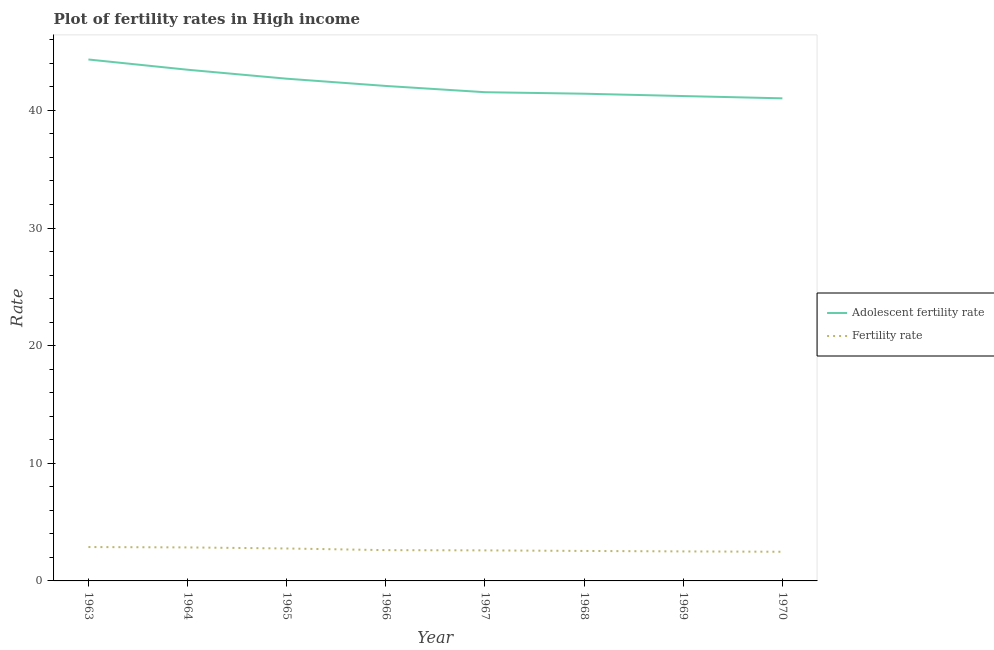How many different coloured lines are there?
Make the answer very short. 2. Is the number of lines equal to the number of legend labels?
Offer a terse response. Yes. What is the adolescent fertility rate in 1969?
Ensure brevity in your answer.  41.22. Across all years, what is the maximum adolescent fertility rate?
Your response must be concise. 44.33. Across all years, what is the minimum adolescent fertility rate?
Provide a short and direct response. 41.03. What is the total adolescent fertility rate in the graph?
Provide a short and direct response. 337.78. What is the difference between the adolescent fertility rate in 1965 and that in 1969?
Offer a terse response. 1.48. What is the difference between the fertility rate in 1964 and the adolescent fertility rate in 1970?
Your answer should be very brief. -38.18. What is the average adolescent fertility rate per year?
Your response must be concise. 42.22. In the year 1970, what is the difference between the adolescent fertility rate and fertility rate?
Give a very brief answer. 38.55. What is the ratio of the fertility rate in 1968 to that in 1970?
Provide a short and direct response. 1.03. What is the difference between the highest and the second highest adolescent fertility rate?
Your response must be concise. 0.87. What is the difference between the highest and the lowest adolescent fertility rate?
Ensure brevity in your answer.  3.3. In how many years, is the adolescent fertility rate greater than the average adolescent fertility rate taken over all years?
Your answer should be very brief. 3. Is the fertility rate strictly less than the adolescent fertility rate over the years?
Make the answer very short. Yes. How many lines are there?
Keep it short and to the point. 2. How many years are there in the graph?
Keep it short and to the point. 8. Does the graph contain any zero values?
Offer a very short reply. No. Does the graph contain grids?
Provide a short and direct response. No. Where does the legend appear in the graph?
Give a very brief answer. Center right. What is the title of the graph?
Give a very brief answer. Plot of fertility rates in High income. What is the label or title of the X-axis?
Your response must be concise. Year. What is the label or title of the Y-axis?
Give a very brief answer. Rate. What is the Rate in Adolescent fertility rate in 1963?
Offer a terse response. 44.33. What is the Rate of Fertility rate in 1963?
Provide a short and direct response. 2.88. What is the Rate in Adolescent fertility rate in 1964?
Ensure brevity in your answer.  43.46. What is the Rate of Fertility rate in 1964?
Your answer should be very brief. 2.85. What is the Rate in Adolescent fertility rate in 1965?
Your answer should be very brief. 42.7. What is the Rate in Fertility rate in 1965?
Give a very brief answer. 2.76. What is the Rate in Adolescent fertility rate in 1966?
Provide a short and direct response. 42.08. What is the Rate of Fertility rate in 1966?
Your response must be concise. 2.62. What is the Rate in Adolescent fertility rate in 1967?
Your answer should be compact. 41.55. What is the Rate of Fertility rate in 1967?
Ensure brevity in your answer.  2.6. What is the Rate of Adolescent fertility rate in 1968?
Provide a succinct answer. 41.42. What is the Rate of Fertility rate in 1968?
Your answer should be compact. 2.55. What is the Rate in Adolescent fertility rate in 1969?
Provide a succinct answer. 41.22. What is the Rate of Fertility rate in 1969?
Ensure brevity in your answer.  2.51. What is the Rate in Adolescent fertility rate in 1970?
Your answer should be compact. 41.03. What is the Rate of Fertility rate in 1970?
Make the answer very short. 2.48. Across all years, what is the maximum Rate in Adolescent fertility rate?
Your answer should be very brief. 44.33. Across all years, what is the maximum Rate of Fertility rate?
Offer a very short reply. 2.88. Across all years, what is the minimum Rate in Adolescent fertility rate?
Your response must be concise. 41.03. Across all years, what is the minimum Rate of Fertility rate?
Give a very brief answer. 2.48. What is the total Rate in Adolescent fertility rate in the graph?
Offer a terse response. 337.78. What is the total Rate in Fertility rate in the graph?
Make the answer very short. 21.24. What is the difference between the Rate of Adolescent fertility rate in 1963 and that in 1964?
Ensure brevity in your answer.  0.87. What is the difference between the Rate of Fertility rate in 1963 and that in 1964?
Give a very brief answer. 0.03. What is the difference between the Rate in Adolescent fertility rate in 1963 and that in 1965?
Provide a short and direct response. 1.63. What is the difference between the Rate in Fertility rate in 1963 and that in 1965?
Offer a very short reply. 0.12. What is the difference between the Rate of Adolescent fertility rate in 1963 and that in 1966?
Provide a short and direct response. 2.25. What is the difference between the Rate in Fertility rate in 1963 and that in 1966?
Give a very brief answer. 0.26. What is the difference between the Rate of Adolescent fertility rate in 1963 and that in 1967?
Your answer should be compact. 2.78. What is the difference between the Rate of Fertility rate in 1963 and that in 1967?
Your answer should be very brief. 0.28. What is the difference between the Rate in Adolescent fertility rate in 1963 and that in 1968?
Keep it short and to the point. 2.91. What is the difference between the Rate of Fertility rate in 1963 and that in 1968?
Your response must be concise. 0.33. What is the difference between the Rate in Adolescent fertility rate in 1963 and that in 1969?
Provide a short and direct response. 3.11. What is the difference between the Rate in Fertility rate in 1963 and that in 1969?
Your answer should be compact. 0.37. What is the difference between the Rate in Adolescent fertility rate in 1963 and that in 1970?
Your answer should be compact. 3.3. What is the difference between the Rate in Fertility rate in 1963 and that in 1970?
Offer a terse response. 0.4. What is the difference between the Rate of Adolescent fertility rate in 1964 and that in 1965?
Give a very brief answer. 0.76. What is the difference between the Rate in Fertility rate in 1964 and that in 1965?
Offer a very short reply. 0.09. What is the difference between the Rate of Adolescent fertility rate in 1964 and that in 1966?
Provide a short and direct response. 1.38. What is the difference between the Rate in Fertility rate in 1964 and that in 1966?
Your response must be concise. 0.23. What is the difference between the Rate in Adolescent fertility rate in 1964 and that in 1967?
Provide a short and direct response. 1.91. What is the difference between the Rate of Fertility rate in 1964 and that in 1967?
Offer a terse response. 0.25. What is the difference between the Rate of Adolescent fertility rate in 1964 and that in 1968?
Your answer should be very brief. 2.04. What is the difference between the Rate of Fertility rate in 1964 and that in 1968?
Offer a terse response. 0.3. What is the difference between the Rate of Adolescent fertility rate in 1964 and that in 1969?
Your answer should be compact. 2.24. What is the difference between the Rate of Fertility rate in 1964 and that in 1969?
Provide a short and direct response. 0.34. What is the difference between the Rate in Adolescent fertility rate in 1964 and that in 1970?
Provide a short and direct response. 2.43. What is the difference between the Rate in Fertility rate in 1964 and that in 1970?
Your answer should be compact. 0.37. What is the difference between the Rate in Adolescent fertility rate in 1965 and that in 1966?
Keep it short and to the point. 0.62. What is the difference between the Rate in Fertility rate in 1965 and that in 1966?
Your response must be concise. 0.14. What is the difference between the Rate in Adolescent fertility rate in 1965 and that in 1967?
Your answer should be compact. 1.15. What is the difference between the Rate in Fertility rate in 1965 and that in 1967?
Your response must be concise. 0.16. What is the difference between the Rate in Adolescent fertility rate in 1965 and that in 1968?
Ensure brevity in your answer.  1.28. What is the difference between the Rate in Fertility rate in 1965 and that in 1968?
Provide a succinct answer. 0.21. What is the difference between the Rate in Adolescent fertility rate in 1965 and that in 1969?
Your answer should be very brief. 1.48. What is the difference between the Rate in Fertility rate in 1965 and that in 1969?
Your answer should be compact. 0.25. What is the difference between the Rate of Adolescent fertility rate in 1965 and that in 1970?
Offer a terse response. 1.67. What is the difference between the Rate of Fertility rate in 1965 and that in 1970?
Offer a terse response. 0.28. What is the difference between the Rate of Adolescent fertility rate in 1966 and that in 1967?
Offer a terse response. 0.53. What is the difference between the Rate in Fertility rate in 1966 and that in 1967?
Provide a succinct answer. 0.02. What is the difference between the Rate of Adolescent fertility rate in 1966 and that in 1968?
Make the answer very short. 0.66. What is the difference between the Rate of Fertility rate in 1966 and that in 1968?
Your answer should be very brief. 0.07. What is the difference between the Rate of Adolescent fertility rate in 1966 and that in 1969?
Provide a succinct answer. 0.86. What is the difference between the Rate in Fertility rate in 1966 and that in 1969?
Give a very brief answer. 0.11. What is the difference between the Rate of Adolescent fertility rate in 1966 and that in 1970?
Ensure brevity in your answer.  1.05. What is the difference between the Rate in Fertility rate in 1966 and that in 1970?
Give a very brief answer. 0.14. What is the difference between the Rate in Adolescent fertility rate in 1967 and that in 1968?
Your answer should be compact. 0.13. What is the difference between the Rate in Fertility rate in 1967 and that in 1968?
Offer a terse response. 0.05. What is the difference between the Rate in Adolescent fertility rate in 1967 and that in 1969?
Your answer should be compact. 0.33. What is the difference between the Rate of Fertility rate in 1967 and that in 1969?
Provide a short and direct response. 0.09. What is the difference between the Rate of Adolescent fertility rate in 1967 and that in 1970?
Your answer should be very brief. 0.52. What is the difference between the Rate of Fertility rate in 1967 and that in 1970?
Your response must be concise. 0.12. What is the difference between the Rate in Adolescent fertility rate in 1968 and that in 1969?
Offer a very short reply. 0.2. What is the difference between the Rate of Fertility rate in 1968 and that in 1969?
Ensure brevity in your answer.  0.04. What is the difference between the Rate in Adolescent fertility rate in 1968 and that in 1970?
Your answer should be very brief. 0.39. What is the difference between the Rate of Fertility rate in 1968 and that in 1970?
Keep it short and to the point. 0.07. What is the difference between the Rate in Adolescent fertility rate in 1969 and that in 1970?
Provide a succinct answer. 0.19. What is the difference between the Rate in Fertility rate in 1969 and that in 1970?
Your answer should be very brief. 0.03. What is the difference between the Rate of Adolescent fertility rate in 1963 and the Rate of Fertility rate in 1964?
Provide a succinct answer. 41.48. What is the difference between the Rate in Adolescent fertility rate in 1963 and the Rate in Fertility rate in 1965?
Make the answer very short. 41.57. What is the difference between the Rate of Adolescent fertility rate in 1963 and the Rate of Fertility rate in 1966?
Your answer should be compact. 41.71. What is the difference between the Rate in Adolescent fertility rate in 1963 and the Rate in Fertility rate in 1967?
Provide a succinct answer. 41.73. What is the difference between the Rate of Adolescent fertility rate in 1963 and the Rate of Fertility rate in 1968?
Keep it short and to the point. 41.78. What is the difference between the Rate in Adolescent fertility rate in 1963 and the Rate in Fertility rate in 1969?
Your answer should be compact. 41.82. What is the difference between the Rate of Adolescent fertility rate in 1963 and the Rate of Fertility rate in 1970?
Ensure brevity in your answer.  41.85. What is the difference between the Rate of Adolescent fertility rate in 1964 and the Rate of Fertility rate in 1965?
Offer a very short reply. 40.7. What is the difference between the Rate of Adolescent fertility rate in 1964 and the Rate of Fertility rate in 1966?
Ensure brevity in your answer.  40.84. What is the difference between the Rate of Adolescent fertility rate in 1964 and the Rate of Fertility rate in 1967?
Make the answer very short. 40.86. What is the difference between the Rate in Adolescent fertility rate in 1964 and the Rate in Fertility rate in 1968?
Make the answer very short. 40.91. What is the difference between the Rate in Adolescent fertility rate in 1964 and the Rate in Fertility rate in 1969?
Offer a very short reply. 40.95. What is the difference between the Rate in Adolescent fertility rate in 1964 and the Rate in Fertility rate in 1970?
Keep it short and to the point. 40.98. What is the difference between the Rate in Adolescent fertility rate in 1965 and the Rate in Fertility rate in 1966?
Ensure brevity in your answer.  40.08. What is the difference between the Rate in Adolescent fertility rate in 1965 and the Rate in Fertility rate in 1967?
Offer a very short reply. 40.1. What is the difference between the Rate of Adolescent fertility rate in 1965 and the Rate of Fertility rate in 1968?
Give a very brief answer. 40.15. What is the difference between the Rate in Adolescent fertility rate in 1965 and the Rate in Fertility rate in 1969?
Make the answer very short. 40.19. What is the difference between the Rate in Adolescent fertility rate in 1965 and the Rate in Fertility rate in 1970?
Your answer should be compact. 40.22. What is the difference between the Rate in Adolescent fertility rate in 1966 and the Rate in Fertility rate in 1967?
Offer a terse response. 39.48. What is the difference between the Rate in Adolescent fertility rate in 1966 and the Rate in Fertility rate in 1968?
Provide a succinct answer. 39.53. What is the difference between the Rate of Adolescent fertility rate in 1966 and the Rate of Fertility rate in 1969?
Provide a succinct answer. 39.57. What is the difference between the Rate in Adolescent fertility rate in 1966 and the Rate in Fertility rate in 1970?
Keep it short and to the point. 39.6. What is the difference between the Rate of Adolescent fertility rate in 1967 and the Rate of Fertility rate in 1968?
Your answer should be very brief. 39. What is the difference between the Rate in Adolescent fertility rate in 1967 and the Rate in Fertility rate in 1969?
Make the answer very short. 39.04. What is the difference between the Rate in Adolescent fertility rate in 1967 and the Rate in Fertility rate in 1970?
Make the answer very short. 39.07. What is the difference between the Rate of Adolescent fertility rate in 1968 and the Rate of Fertility rate in 1969?
Keep it short and to the point. 38.91. What is the difference between the Rate in Adolescent fertility rate in 1968 and the Rate in Fertility rate in 1970?
Provide a succinct answer. 38.94. What is the difference between the Rate in Adolescent fertility rate in 1969 and the Rate in Fertility rate in 1970?
Your response must be concise. 38.74. What is the average Rate of Adolescent fertility rate per year?
Your answer should be very brief. 42.22. What is the average Rate of Fertility rate per year?
Keep it short and to the point. 2.65. In the year 1963, what is the difference between the Rate of Adolescent fertility rate and Rate of Fertility rate?
Keep it short and to the point. 41.45. In the year 1964, what is the difference between the Rate in Adolescent fertility rate and Rate in Fertility rate?
Your answer should be very brief. 40.61. In the year 1965, what is the difference between the Rate of Adolescent fertility rate and Rate of Fertility rate?
Ensure brevity in your answer.  39.94. In the year 1966, what is the difference between the Rate of Adolescent fertility rate and Rate of Fertility rate?
Give a very brief answer. 39.46. In the year 1967, what is the difference between the Rate of Adolescent fertility rate and Rate of Fertility rate?
Your answer should be compact. 38.95. In the year 1968, what is the difference between the Rate of Adolescent fertility rate and Rate of Fertility rate?
Your answer should be compact. 38.87. In the year 1969, what is the difference between the Rate of Adolescent fertility rate and Rate of Fertility rate?
Your response must be concise. 38.71. In the year 1970, what is the difference between the Rate in Adolescent fertility rate and Rate in Fertility rate?
Give a very brief answer. 38.55. What is the ratio of the Rate in Adolescent fertility rate in 1963 to that in 1964?
Give a very brief answer. 1.02. What is the ratio of the Rate in Fertility rate in 1963 to that in 1964?
Ensure brevity in your answer.  1.01. What is the ratio of the Rate of Adolescent fertility rate in 1963 to that in 1965?
Offer a terse response. 1.04. What is the ratio of the Rate of Fertility rate in 1963 to that in 1965?
Provide a short and direct response. 1.04. What is the ratio of the Rate of Adolescent fertility rate in 1963 to that in 1966?
Make the answer very short. 1.05. What is the ratio of the Rate in Fertility rate in 1963 to that in 1966?
Your answer should be very brief. 1.1. What is the ratio of the Rate in Adolescent fertility rate in 1963 to that in 1967?
Provide a succinct answer. 1.07. What is the ratio of the Rate of Fertility rate in 1963 to that in 1967?
Provide a succinct answer. 1.11. What is the ratio of the Rate of Adolescent fertility rate in 1963 to that in 1968?
Provide a succinct answer. 1.07. What is the ratio of the Rate in Fertility rate in 1963 to that in 1968?
Ensure brevity in your answer.  1.13. What is the ratio of the Rate in Adolescent fertility rate in 1963 to that in 1969?
Offer a terse response. 1.08. What is the ratio of the Rate in Fertility rate in 1963 to that in 1969?
Make the answer very short. 1.15. What is the ratio of the Rate in Adolescent fertility rate in 1963 to that in 1970?
Offer a terse response. 1.08. What is the ratio of the Rate of Fertility rate in 1963 to that in 1970?
Your answer should be very brief. 1.16. What is the ratio of the Rate of Adolescent fertility rate in 1964 to that in 1965?
Give a very brief answer. 1.02. What is the ratio of the Rate in Fertility rate in 1964 to that in 1965?
Provide a short and direct response. 1.03. What is the ratio of the Rate of Adolescent fertility rate in 1964 to that in 1966?
Provide a succinct answer. 1.03. What is the ratio of the Rate in Fertility rate in 1964 to that in 1966?
Your response must be concise. 1.09. What is the ratio of the Rate of Adolescent fertility rate in 1964 to that in 1967?
Your answer should be very brief. 1.05. What is the ratio of the Rate in Fertility rate in 1964 to that in 1967?
Your response must be concise. 1.1. What is the ratio of the Rate in Adolescent fertility rate in 1964 to that in 1968?
Provide a short and direct response. 1.05. What is the ratio of the Rate in Fertility rate in 1964 to that in 1968?
Your answer should be very brief. 1.12. What is the ratio of the Rate of Adolescent fertility rate in 1964 to that in 1969?
Make the answer very short. 1.05. What is the ratio of the Rate of Fertility rate in 1964 to that in 1969?
Provide a short and direct response. 1.14. What is the ratio of the Rate in Adolescent fertility rate in 1964 to that in 1970?
Offer a terse response. 1.06. What is the ratio of the Rate in Fertility rate in 1964 to that in 1970?
Ensure brevity in your answer.  1.15. What is the ratio of the Rate in Adolescent fertility rate in 1965 to that in 1966?
Offer a terse response. 1.01. What is the ratio of the Rate of Fertility rate in 1965 to that in 1966?
Offer a terse response. 1.05. What is the ratio of the Rate of Adolescent fertility rate in 1965 to that in 1967?
Provide a succinct answer. 1.03. What is the ratio of the Rate in Fertility rate in 1965 to that in 1967?
Ensure brevity in your answer.  1.06. What is the ratio of the Rate in Adolescent fertility rate in 1965 to that in 1968?
Your answer should be very brief. 1.03. What is the ratio of the Rate in Fertility rate in 1965 to that in 1968?
Your answer should be very brief. 1.08. What is the ratio of the Rate in Adolescent fertility rate in 1965 to that in 1969?
Your answer should be very brief. 1.04. What is the ratio of the Rate in Fertility rate in 1965 to that in 1969?
Offer a very short reply. 1.1. What is the ratio of the Rate of Adolescent fertility rate in 1965 to that in 1970?
Provide a succinct answer. 1.04. What is the ratio of the Rate of Fertility rate in 1965 to that in 1970?
Give a very brief answer. 1.11. What is the ratio of the Rate in Adolescent fertility rate in 1966 to that in 1967?
Your answer should be compact. 1.01. What is the ratio of the Rate of Fertility rate in 1966 to that in 1967?
Make the answer very short. 1.01. What is the ratio of the Rate in Adolescent fertility rate in 1966 to that in 1968?
Offer a very short reply. 1.02. What is the ratio of the Rate in Fertility rate in 1966 to that in 1968?
Provide a short and direct response. 1.03. What is the ratio of the Rate in Adolescent fertility rate in 1966 to that in 1969?
Your answer should be compact. 1.02. What is the ratio of the Rate in Fertility rate in 1966 to that in 1969?
Make the answer very short. 1.04. What is the ratio of the Rate of Adolescent fertility rate in 1966 to that in 1970?
Provide a succinct answer. 1.03. What is the ratio of the Rate of Fertility rate in 1966 to that in 1970?
Your answer should be very brief. 1.06. What is the ratio of the Rate in Fertility rate in 1967 to that in 1968?
Your response must be concise. 1.02. What is the ratio of the Rate in Adolescent fertility rate in 1967 to that in 1969?
Ensure brevity in your answer.  1.01. What is the ratio of the Rate in Fertility rate in 1967 to that in 1969?
Provide a short and direct response. 1.04. What is the ratio of the Rate of Adolescent fertility rate in 1967 to that in 1970?
Your answer should be very brief. 1.01. What is the ratio of the Rate in Fertility rate in 1967 to that in 1970?
Offer a terse response. 1.05. What is the ratio of the Rate in Fertility rate in 1968 to that in 1969?
Give a very brief answer. 1.02. What is the ratio of the Rate in Adolescent fertility rate in 1968 to that in 1970?
Offer a very short reply. 1.01. What is the ratio of the Rate in Fertility rate in 1968 to that in 1970?
Your answer should be very brief. 1.03. What is the ratio of the Rate of Adolescent fertility rate in 1969 to that in 1970?
Ensure brevity in your answer.  1. What is the ratio of the Rate in Fertility rate in 1969 to that in 1970?
Offer a very short reply. 1.01. What is the difference between the highest and the second highest Rate of Adolescent fertility rate?
Provide a succinct answer. 0.87. What is the difference between the highest and the second highest Rate of Fertility rate?
Offer a terse response. 0.03. What is the difference between the highest and the lowest Rate of Adolescent fertility rate?
Offer a very short reply. 3.3. What is the difference between the highest and the lowest Rate of Fertility rate?
Your answer should be compact. 0.4. 